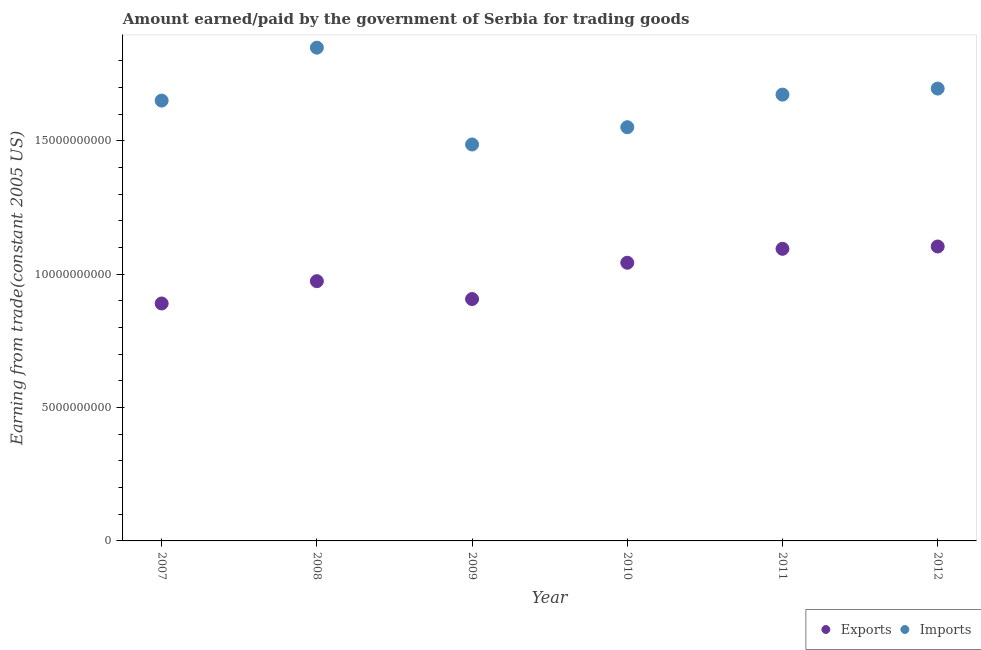How many different coloured dotlines are there?
Your answer should be very brief. 2. What is the amount paid for imports in 2008?
Provide a succinct answer. 1.85e+1. Across all years, what is the maximum amount earned from exports?
Provide a short and direct response. 1.10e+1. Across all years, what is the minimum amount earned from exports?
Your answer should be compact. 8.90e+09. What is the total amount earned from exports in the graph?
Ensure brevity in your answer.  6.01e+1. What is the difference between the amount paid for imports in 2008 and that in 2009?
Your answer should be very brief. 3.63e+09. What is the difference between the amount paid for imports in 2010 and the amount earned from exports in 2009?
Your response must be concise. 6.44e+09. What is the average amount earned from exports per year?
Your response must be concise. 1.00e+1. In the year 2012, what is the difference between the amount earned from exports and amount paid for imports?
Provide a short and direct response. -5.92e+09. What is the ratio of the amount earned from exports in 2009 to that in 2010?
Provide a short and direct response. 0.87. Is the amount paid for imports in 2009 less than that in 2012?
Give a very brief answer. Yes. Is the difference between the amount earned from exports in 2008 and 2009 greater than the difference between the amount paid for imports in 2008 and 2009?
Ensure brevity in your answer.  No. What is the difference between the highest and the second highest amount earned from exports?
Offer a terse response. 8.77e+07. What is the difference between the highest and the lowest amount paid for imports?
Give a very brief answer. 3.63e+09. In how many years, is the amount paid for imports greater than the average amount paid for imports taken over all years?
Keep it short and to the point. 3. How many dotlines are there?
Provide a succinct answer. 2. How many years are there in the graph?
Offer a terse response. 6. Are the values on the major ticks of Y-axis written in scientific E-notation?
Provide a short and direct response. No. Does the graph contain any zero values?
Offer a terse response. No. How are the legend labels stacked?
Make the answer very short. Horizontal. What is the title of the graph?
Your answer should be compact. Amount earned/paid by the government of Serbia for trading goods. Does "Not attending school" appear as one of the legend labels in the graph?
Keep it short and to the point. No. What is the label or title of the X-axis?
Provide a short and direct response. Year. What is the label or title of the Y-axis?
Make the answer very short. Earning from trade(constant 2005 US). What is the Earning from trade(constant 2005 US) of Exports in 2007?
Keep it short and to the point. 8.90e+09. What is the Earning from trade(constant 2005 US) of Imports in 2007?
Give a very brief answer. 1.65e+1. What is the Earning from trade(constant 2005 US) in Exports in 2008?
Your answer should be very brief. 9.74e+09. What is the Earning from trade(constant 2005 US) in Imports in 2008?
Keep it short and to the point. 1.85e+1. What is the Earning from trade(constant 2005 US) in Exports in 2009?
Your answer should be very brief. 9.07e+09. What is the Earning from trade(constant 2005 US) of Imports in 2009?
Keep it short and to the point. 1.49e+1. What is the Earning from trade(constant 2005 US) in Exports in 2010?
Your answer should be very brief. 1.04e+1. What is the Earning from trade(constant 2005 US) in Imports in 2010?
Make the answer very short. 1.55e+1. What is the Earning from trade(constant 2005 US) of Exports in 2011?
Keep it short and to the point. 1.10e+1. What is the Earning from trade(constant 2005 US) of Imports in 2011?
Keep it short and to the point. 1.67e+1. What is the Earning from trade(constant 2005 US) of Exports in 2012?
Provide a succinct answer. 1.10e+1. What is the Earning from trade(constant 2005 US) in Imports in 2012?
Your answer should be compact. 1.70e+1. Across all years, what is the maximum Earning from trade(constant 2005 US) in Exports?
Your answer should be very brief. 1.10e+1. Across all years, what is the maximum Earning from trade(constant 2005 US) of Imports?
Provide a succinct answer. 1.85e+1. Across all years, what is the minimum Earning from trade(constant 2005 US) in Exports?
Your response must be concise. 8.90e+09. Across all years, what is the minimum Earning from trade(constant 2005 US) in Imports?
Provide a short and direct response. 1.49e+1. What is the total Earning from trade(constant 2005 US) of Exports in the graph?
Offer a terse response. 6.01e+1. What is the total Earning from trade(constant 2005 US) of Imports in the graph?
Provide a short and direct response. 9.91e+1. What is the difference between the Earning from trade(constant 2005 US) of Exports in 2007 and that in 2008?
Your response must be concise. -8.36e+08. What is the difference between the Earning from trade(constant 2005 US) in Imports in 2007 and that in 2008?
Offer a terse response. -1.98e+09. What is the difference between the Earning from trade(constant 2005 US) in Exports in 2007 and that in 2009?
Give a very brief answer. -1.65e+08. What is the difference between the Earning from trade(constant 2005 US) of Imports in 2007 and that in 2009?
Offer a terse response. 1.65e+09. What is the difference between the Earning from trade(constant 2005 US) in Exports in 2007 and that in 2010?
Your answer should be compact. -1.53e+09. What is the difference between the Earning from trade(constant 2005 US) in Imports in 2007 and that in 2010?
Your answer should be very brief. 9.98e+08. What is the difference between the Earning from trade(constant 2005 US) in Exports in 2007 and that in 2011?
Your answer should be compact. -2.05e+09. What is the difference between the Earning from trade(constant 2005 US) of Imports in 2007 and that in 2011?
Provide a short and direct response. -2.24e+08. What is the difference between the Earning from trade(constant 2005 US) in Exports in 2007 and that in 2012?
Keep it short and to the point. -2.14e+09. What is the difference between the Earning from trade(constant 2005 US) of Imports in 2007 and that in 2012?
Ensure brevity in your answer.  -4.51e+08. What is the difference between the Earning from trade(constant 2005 US) in Exports in 2008 and that in 2009?
Your answer should be very brief. 6.70e+08. What is the difference between the Earning from trade(constant 2005 US) in Imports in 2008 and that in 2009?
Your answer should be compact. 3.63e+09. What is the difference between the Earning from trade(constant 2005 US) of Exports in 2008 and that in 2010?
Your answer should be compact. -6.91e+08. What is the difference between the Earning from trade(constant 2005 US) in Imports in 2008 and that in 2010?
Your response must be concise. 2.98e+09. What is the difference between the Earning from trade(constant 2005 US) of Exports in 2008 and that in 2011?
Provide a short and direct response. -1.21e+09. What is the difference between the Earning from trade(constant 2005 US) in Imports in 2008 and that in 2011?
Provide a short and direct response. 1.76e+09. What is the difference between the Earning from trade(constant 2005 US) of Exports in 2008 and that in 2012?
Provide a succinct answer. -1.30e+09. What is the difference between the Earning from trade(constant 2005 US) in Imports in 2008 and that in 2012?
Keep it short and to the point. 1.53e+09. What is the difference between the Earning from trade(constant 2005 US) of Exports in 2009 and that in 2010?
Keep it short and to the point. -1.36e+09. What is the difference between the Earning from trade(constant 2005 US) in Imports in 2009 and that in 2010?
Your response must be concise. -6.48e+08. What is the difference between the Earning from trade(constant 2005 US) of Exports in 2009 and that in 2011?
Provide a short and direct response. -1.88e+09. What is the difference between the Earning from trade(constant 2005 US) in Imports in 2009 and that in 2011?
Offer a terse response. -1.87e+09. What is the difference between the Earning from trade(constant 2005 US) in Exports in 2009 and that in 2012?
Give a very brief answer. -1.97e+09. What is the difference between the Earning from trade(constant 2005 US) of Imports in 2009 and that in 2012?
Your response must be concise. -2.10e+09. What is the difference between the Earning from trade(constant 2005 US) of Exports in 2010 and that in 2011?
Offer a terse response. -5.22e+08. What is the difference between the Earning from trade(constant 2005 US) of Imports in 2010 and that in 2011?
Your answer should be compact. -1.22e+09. What is the difference between the Earning from trade(constant 2005 US) of Exports in 2010 and that in 2012?
Offer a terse response. -6.09e+08. What is the difference between the Earning from trade(constant 2005 US) in Imports in 2010 and that in 2012?
Make the answer very short. -1.45e+09. What is the difference between the Earning from trade(constant 2005 US) in Exports in 2011 and that in 2012?
Your response must be concise. -8.77e+07. What is the difference between the Earning from trade(constant 2005 US) in Imports in 2011 and that in 2012?
Your answer should be compact. -2.26e+08. What is the difference between the Earning from trade(constant 2005 US) of Exports in 2007 and the Earning from trade(constant 2005 US) of Imports in 2008?
Make the answer very short. -9.59e+09. What is the difference between the Earning from trade(constant 2005 US) in Exports in 2007 and the Earning from trade(constant 2005 US) in Imports in 2009?
Make the answer very short. -5.96e+09. What is the difference between the Earning from trade(constant 2005 US) in Exports in 2007 and the Earning from trade(constant 2005 US) in Imports in 2010?
Ensure brevity in your answer.  -6.61e+09. What is the difference between the Earning from trade(constant 2005 US) in Exports in 2007 and the Earning from trade(constant 2005 US) in Imports in 2011?
Make the answer very short. -7.83e+09. What is the difference between the Earning from trade(constant 2005 US) in Exports in 2007 and the Earning from trade(constant 2005 US) in Imports in 2012?
Offer a terse response. -8.06e+09. What is the difference between the Earning from trade(constant 2005 US) of Exports in 2008 and the Earning from trade(constant 2005 US) of Imports in 2009?
Your answer should be very brief. -5.12e+09. What is the difference between the Earning from trade(constant 2005 US) of Exports in 2008 and the Earning from trade(constant 2005 US) of Imports in 2010?
Your answer should be compact. -5.77e+09. What is the difference between the Earning from trade(constant 2005 US) of Exports in 2008 and the Earning from trade(constant 2005 US) of Imports in 2011?
Provide a succinct answer. -6.99e+09. What is the difference between the Earning from trade(constant 2005 US) in Exports in 2008 and the Earning from trade(constant 2005 US) in Imports in 2012?
Your answer should be very brief. -7.22e+09. What is the difference between the Earning from trade(constant 2005 US) of Exports in 2009 and the Earning from trade(constant 2005 US) of Imports in 2010?
Provide a short and direct response. -6.44e+09. What is the difference between the Earning from trade(constant 2005 US) in Exports in 2009 and the Earning from trade(constant 2005 US) in Imports in 2011?
Keep it short and to the point. -7.66e+09. What is the difference between the Earning from trade(constant 2005 US) of Exports in 2009 and the Earning from trade(constant 2005 US) of Imports in 2012?
Make the answer very short. -7.89e+09. What is the difference between the Earning from trade(constant 2005 US) in Exports in 2010 and the Earning from trade(constant 2005 US) in Imports in 2011?
Give a very brief answer. -6.30e+09. What is the difference between the Earning from trade(constant 2005 US) of Exports in 2010 and the Earning from trade(constant 2005 US) of Imports in 2012?
Make the answer very short. -6.53e+09. What is the difference between the Earning from trade(constant 2005 US) of Exports in 2011 and the Earning from trade(constant 2005 US) of Imports in 2012?
Ensure brevity in your answer.  -6.01e+09. What is the average Earning from trade(constant 2005 US) of Exports per year?
Offer a terse response. 1.00e+1. What is the average Earning from trade(constant 2005 US) of Imports per year?
Provide a succinct answer. 1.65e+1. In the year 2007, what is the difference between the Earning from trade(constant 2005 US) of Exports and Earning from trade(constant 2005 US) of Imports?
Offer a terse response. -7.61e+09. In the year 2008, what is the difference between the Earning from trade(constant 2005 US) of Exports and Earning from trade(constant 2005 US) of Imports?
Give a very brief answer. -8.75e+09. In the year 2009, what is the difference between the Earning from trade(constant 2005 US) in Exports and Earning from trade(constant 2005 US) in Imports?
Ensure brevity in your answer.  -5.79e+09. In the year 2010, what is the difference between the Earning from trade(constant 2005 US) of Exports and Earning from trade(constant 2005 US) of Imports?
Your answer should be compact. -5.08e+09. In the year 2011, what is the difference between the Earning from trade(constant 2005 US) of Exports and Earning from trade(constant 2005 US) of Imports?
Provide a succinct answer. -5.78e+09. In the year 2012, what is the difference between the Earning from trade(constant 2005 US) of Exports and Earning from trade(constant 2005 US) of Imports?
Give a very brief answer. -5.92e+09. What is the ratio of the Earning from trade(constant 2005 US) in Exports in 2007 to that in 2008?
Offer a very short reply. 0.91. What is the ratio of the Earning from trade(constant 2005 US) in Imports in 2007 to that in 2008?
Your response must be concise. 0.89. What is the ratio of the Earning from trade(constant 2005 US) of Exports in 2007 to that in 2009?
Give a very brief answer. 0.98. What is the ratio of the Earning from trade(constant 2005 US) of Imports in 2007 to that in 2009?
Give a very brief answer. 1.11. What is the ratio of the Earning from trade(constant 2005 US) in Exports in 2007 to that in 2010?
Give a very brief answer. 0.85. What is the ratio of the Earning from trade(constant 2005 US) in Imports in 2007 to that in 2010?
Make the answer very short. 1.06. What is the ratio of the Earning from trade(constant 2005 US) of Exports in 2007 to that in 2011?
Provide a short and direct response. 0.81. What is the ratio of the Earning from trade(constant 2005 US) of Imports in 2007 to that in 2011?
Provide a succinct answer. 0.99. What is the ratio of the Earning from trade(constant 2005 US) in Exports in 2007 to that in 2012?
Keep it short and to the point. 0.81. What is the ratio of the Earning from trade(constant 2005 US) of Imports in 2007 to that in 2012?
Give a very brief answer. 0.97. What is the ratio of the Earning from trade(constant 2005 US) of Exports in 2008 to that in 2009?
Give a very brief answer. 1.07. What is the ratio of the Earning from trade(constant 2005 US) in Imports in 2008 to that in 2009?
Your response must be concise. 1.24. What is the ratio of the Earning from trade(constant 2005 US) in Exports in 2008 to that in 2010?
Your answer should be very brief. 0.93. What is the ratio of the Earning from trade(constant 2005 US) in Imports in 2008 to that in 2010?
Provide a short and direct response. 1.19. What is the ratio of the Earning from trade(constant 2005 US) in Exports in 2008 to that in 2011?
Give a very brief answer. 0.89. What is the ratio of the Earning from trade(constant 2005 US) in Imports in 2008 to that in 2011?
Keep it short and to the point. 1.11. What is the ratio of the Earning from trade(constant 2005 US) of Exports in 2008 to that in 2012?
Give a very brief answer. 0.88. What is the ratio of the Earning from trade(constant 2005 US) in Imports in 2008 to that in 2012?
Your answer should be very brief. 1.09. What is the ratio of the Earning from trade(constant 2005 US) of Exports in 2009 to that in 2010?
Give a very brief answer. 0.87. What is the ratio of the Earning from trade(constant 2005 US) in Imports in 2009 to that in 2010?
Make the answer very short. 0.96. What is the ratio of the Earning from trade(constant 2005 US) in Exports in 2009 to that in 2011?
Ensure brevity in your answer.  0.83. What is the ratio of the Earning from trade(constant 2005 US) in Imports in 2009 to that in 2011?
Keep it short and to the point. 0.89. What is the ratio of the Earning from trade(constant 2005 US) of Exports in 2009 to that in 2012?
Provide a short and direct response. 0.82. What is the ratio of the Earning from trade(constant 2005 US) of Imports in 2009 to that in 2012?
Make the answer very short. 0.88. What is the ratio of the Earning from trade(constant 2005 US) of Exports in 2010 to that in 2011?
Provide a short and direct response. 0.95. What is the ratio of the Earning from trade(constant 2005 US) in Imports in 2010 to that in 2011?
Keep it short and to the point. 0.93. What is the ratio of the Earning from trade(constant 2005 US) of Exports in 2010 to that in 2012?
Make the answer very short. 0.94. What is the ratio of the Earning from trade(constant 2005 US) in Imports in 2010 to that in 2012?
Ensure brevity in your answer.  0.91. What is the ratio of the Earning from trade(constant 2005 US) of Exports in 2011 to that in 2012?
Offer a terse response. 0.99. What is the ratio of the Earning from trade(constant 2005 US) in Imports in 2011 to that in 2012?
Provide a short and direct response. 0.99. What is the difference between the highest and the second highest Earning from trade(constant 2005 US) of Exports?
Make the answer very short. 8.77e+07. What is the difference between the highest and the second highest Earning from trade(constant 2005 US) of Imports?
Ensure brevity in your answer.  1.53e+09. What is the difference between the highest and the lowest Earning from trade(constant 2005 US) in Exports?
Your response must be concise. 2.14e+09. What is the difference between the highest and the lowest Earning from trade(constant 2005 US) in Imports?
Keep it short and to the point. 3.63e+09. 